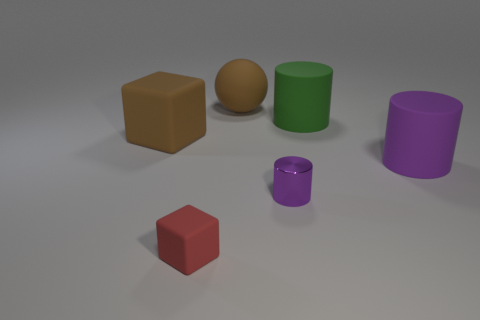Is there anything else that has the same material as the small purple object?
Provide a succinct answer. No. Do the matte sphere and the green matte cylinder have the same size?
Make the answer very short. Yes. Are there fewer big cylinders that are on the left side of the green rubber cylinder than large brown rubber balls that are in front of the ball?
Ensure brevity in your answer.  No. There is a object that is to the right of the red rubber cube and to the left of the tiny metallic cylinder; how big is it?
Your answer should be very brief. Large. Are there any purple objects that are on the left side of the big brown thing behind the large brown matte thing left of the tiny matte thing?
Keep it short and to the point. No. Is there a large cyan shiny sphere?
Ensure brevity in your answer.  No. Is the number of big green rubber cylinders left of the large rubber sphere greater than the number of purple cylinders that are left of the tiny shiny cylinder?
Offer a very short reply. No. There is a red block that is the same material as the green cylinder; what size is it?
Your response must be concise. Small. How big is the brown thing that is on the right side of the block on the right side of the brown matte object that is in front of the large green rubber cylinder?
Offer a terse response. Large. What color is the large object that is left of the red thing?
Keep it short and to the point. Brown. 